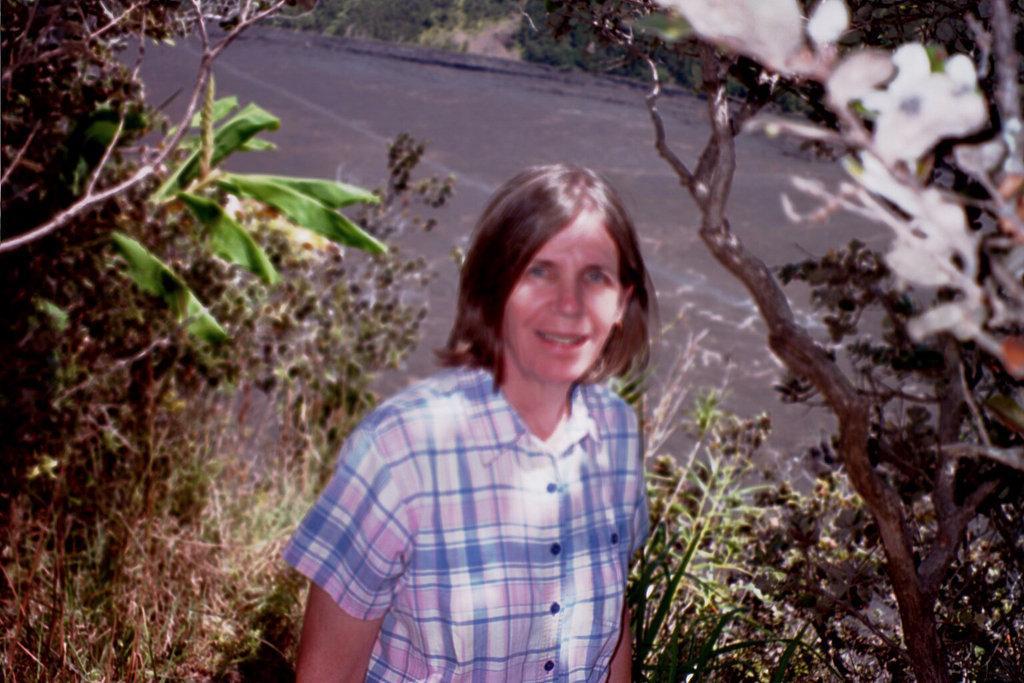Please provide a concise description of this image. This image is taken outdoors. In the middle of the image a woman is standing on the ground. At the bottom of the image there are a few trees and plants. In the background there is a road. 